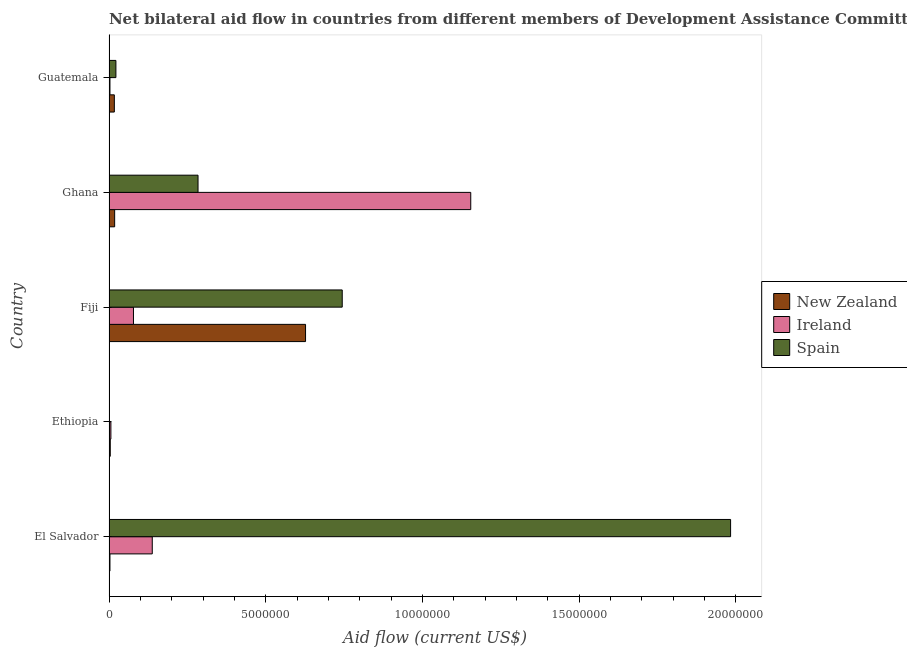Are the number of bars on each tick of the Y-axis equal?
Offer a very short reply. No. How many bars are there on the 3rd tick from the top?
Provide a succinct answer. 3. What is the label of the 5th group of bars from the top?
Keep it short and to the point. El Salvador. In how many cases, is the number of bars for a given country not equal to the number of legend labels?
Ensure brevity in your answer.  1. What is the amount of aid provided by spain in El Salvador?
Make the answer very short. 1.98e+07. Across all countries, what is the maximum amount of aid provided by spain?
Provide a short and direct response. 1.98e+07. Across all countries, what is the minimum amount of aid provided by ireland?
Keep it short and to the point. 3.00e+04. In which country was the amount of aid provided by new zealand maximum?
Offer a very short reply. Fiji. What is the total amount of aid provided by spain in the graph?
Offer a very short reply. 3.03e+07. What is the difference between the amount of aid provided by ireland in Ethiopia and that in Ghana?
Give a very brief answer. -1.15e+07. What is the difference between the amount of aid provided by ireland in Fiji and the amount of aid provided by new zealand in Ethiopia?
Ensure brevity in your answer.  7.40e+05. What is the average amount of aid provided by new zealand per country?
Provide a succinct answer. 1.34e+06. What is the difference between the amount of aid provided by new zealand and amount of aid provided by ireland in Fiji?
Ensure brevity in your answer.  5.49e+06. In how many countries, is the amount of aid provided by ireland greater than 17000000 US$?
Provide a succinct answer. 0. What is the ratio of the amount of aid provided by spain in El Salvador to that in Fiji?
Offer a very short reply. 2.67. Is the amount of aid provided by new zealand in Fiji less than that in Ghana?
Offer a very short reply. No. Is the difference between the amount of aid provided by ireland in Fiji and Ghana greater than the difference between the amount of aid provided by new zealand in Fiji and Ghana?
Ensure brevity in your answer.  No. What is the difference between the highest and the second highest amount of aid provided by ireland?
Offer a very short reply. 1.02e+07. What is the difference between the highest and the lowest amount of aid provided by ireland?
Keep it short and to the point. 1.15e+07. In how many countries, is the amount of aid provided by ireland greater than the average amount of aid provided by ireland taken over all countries?
Your answer should be compact. 1. Is the sum of the amount of aid provided by new zealand in Fiji and Ghana greater than the maximum amount of aid provided by spain across all countries?
Your answer should be compact. No. How many bars are there?
Your response must be concise. 14. Are all the bars in the graph horizontal?
Your answer should be compact. Yes. How many countries are there in the graph?
Provide a succinct answer. 5. Are the values on the major ticks of X-axis written in scientific E-notation?
Provide a succinct answer. No. Does the graph contain any zero values?
Your answer should be very brief. Yes. How are the legend labels stacked?
Your answer should be compact. Vertical. What is the title of the graph?
Your response must be concise. Net bilateral aid flow in countries from different members of Development Assistance Committee. Does "Manufactures" appear as one of the legend labels in the graph?
Ensure brevity in your answer.  No. What is the label or title of the X-axis?
Offer a terse response. Aid flow (current US$). What is the Aid flow (current US$) of New Zealand in El Salvador?
Keep it short and to the point. 3.00e+04. What is the Aid flow (current US$) in Ireland in El Salvador?
Your answer should be compact. 1.38e+06. What is the Aid flow (current US$) in Spain in El Salvador?
Your answer should be compact. 1.98e+07. What is the Aid flow (current US$) of Ireland in Ethiopia?
Your answer should be compact. 6.00e+04. What is the Aid flow (current US$) of New Zealand in Fiji?
Make the answer very short. 6.27e+06. What is the Aid flow (current US$) of Ireland in Fiji?
Give a very brief answer. 7.80e+05. What is the Aid flow (current US$) of Spain in Fiji?
Keep it short and to the point. 7.44e+06. What is the Aid flow (current US$) of Ireland in Ghana?
Provide a short and direct response. 1.15e+07. What is the Aid flow (current US$) in Spain in Ghana?
Ensure brevity in your answer.  2.84e+06. What is the Aid flow (current US$) of Spain in Guatemala?
Offer a terse response. 2.20e+05. Across all countries, what is the maximum Aid flow (current US$) of New Zealand?
Keep it short and to the point. 6.27e+06. Across all countries, what is the maximum Aid flow (current US$) in Ireland?
Provide a short and direct response. 1.15e+07. Across all countries, what is the maximum Aid flow (current US$) in Spain?
Your answer should be compact. 1.98e+07. Across all countries, what is the minimum Aid flow (current US$) in New Zealand?
Your response must be concise. 3.00e+04. Across all countries, what is the minimum Aid flow (current US$) in Spain?
Give a very brief answer. 0. What is the total Aid flow (current US$) in New Zealand in the graph?
Keep it short and to the point. 6.69e+06. What is the total Aid flow (current US$) in Ireland in the graph?
Your answer should be compact. 1.38e+07. What is the total Aid flow (current US$) of Spain in the graph?
Provide a succinct answer. 3.03e+07. What is the difference between the Aid flow (current US$) in Ireland in El Salvador and that in Ethiopia?
Your answer should be compact. 1.32e+06. What is the difference between the Aid flow (current US$) of New Zealand in El Salvador and that in Fiji?
Your answer should be very brief. -6.24e+06. What is the difference between the Aid flow (current US$) of Ireland in El Salvador and that in Fiji?
Give a very brief answer. 6.00e+05. What is the difference between the Aid flow (current US$) in Spain in El Salvador and that in Fiji?
Give a very brief answer. 1.24e+07. What is the difference between the Aid flow (current US$) of New Zealand in El Salvador and that in Ghana?
Make the answer very short. -1.50e+05. What is the difference between the Aid flow (current US$) of Ireland in El Salvador and that in Ghana?
Offer a very short reply. -1.02e+07. What is the difference between the Aid flow (current US$) in Spain in El Salvador and that in Ghana?
Your answer should be very brief. 1.70e+07. What is the difference between the Aid flow (current US$) of Ireland in El Salvador and that in Guatemala?
Provide a succinct answer. 1.35e+06. What is the difference between the Aid flow (current US$) in Spain in El Salvador and that in Guatemala?
Make the answer very short. 1.96e+07. What is the difference between the Aid flow (current US$) in New Zealand in Ethiopia and that in Fiji?
Provide a succinct answer. -6.23e+06. What is the difference between the Aid flow (current US$) in Ireland in Ethiopia and that in Fiji?
Provide a succinct answer. -7.20e+05. What is the difference between the Aid flow (current US$) in New Zealand in Ethiopia and that in Ghana?
Provide a succinct answer. -1.40e+05. What is the difference between the Aid flow (current US$) in Ireland in Ethiopia and that in Ghana?
Provide a succinct answer. -1.15e+07. What is the difference between the Aid flow (current US$) in Ireland in Ethiopia and that in Guatemala?
Offer a terse response. 3.00e+04. What is the difference between the Aid flow (current US$) of New Zealand in Fiji and that in Ghana?
Keep it short and to the point. 6.09e+06. What is the difference between the Aid flow (current US$) in Ireland in Fiji and that in Ghana?
Your answer should be compact. -1.08e+07. What is the difference between the Aid flow (current US$) of Spain in Fiji and that in Ghana?
Give a very brief answer. 4.60e+06. What is the difference between the Aid flow (current US$) in New Zealand in Fiji and that in Guatemala?
Your answer should be very brief. 6.10e+06. What is the difference between the Aid flow (current US$) in Ireland in Fiji and that in Guatemala?
Make the answer very short. 7.50e+05. What is the difference between the Aid flow (current US$) in Spain in Fiji and that in Guatemala?
Provide a short and direct response. 7.22e+06. What is the difference between the Aid flow (current US$) in Ireland in Ghana and that in Guatemala?
Provide a succinct answer. 1.15e+07. What is the difference between the Aid flow (current US$) in Spain in Ghana and that in Guatemala?
Offer a terse response. 2.62e+06. What is the difference between the Aid flow (current US$) of New Zealand in El Salvador and the Aid flow (current US$) of Ireland in Ethiopia?
Your response must be concise. -3.00e+04. What is the difference between the Aid flow (current US$) of New Zealand in El Salvador and the Aid flow (current US$) of Ireland in Fiji?
Your response must be concise. -7.50e+05. What is the difference between the Aid flow (current US$) in New Zealand in El Salvador and the Aid flow (current US$) in Spain in Fiji?
Your response must be concise. -7.41e+06. What is the difference between the Aid flow (current US$) of Ireland in El Salvador and the Aid flow (current US$) of Spain in Fiji?
Give a very brief answer. -6.06e+06. What is the difference between the Aid flow (current US$) of New Zealand in El Salvador and the Aid flow (current US$) of Ireland in Ghana?
Provide a succinct answer. -1.15e+07. What is the difference between the Aid flow (current US$) of New Zealand in El Salvador and the Aid flow (current US$) of Spain in Ghana?
Give a very brief answer. -2.81e+06. What is the difference between the Aid flow (current US$) of Ireland in El Salvador and the Aid flow (current US$) of Spain in Ghana?
Ensure brevity in your answer.  -1.46e+06. What is the difference between the Aid flow (current US$) in Ireland in El Salvador and the Aid flow (current US$) in Spain in Guatemala?
Your answer should be compact. 1.16e+06. What is the difference between the Aid flow (current US$) in New Zealand in Ethiopia and the Aid flow (current US$) in Ireland in Fiji?
Offer a terse response. -7.40e+05. What is the difference between the Aid flow (current US$) of New Zealand in Ethiopia and the Aid flow (current US$) of Spain in Fiji?
Offer a very short reply. -7.40e+06. What is the difference between the Aid flow (current US$) in Ireland in Ethiopia and the Aid flow (current US$) in Spain in Fiji?
Your response must be concise. -7.38e+06. What is the difference between the Aid flow (current US$) in New Zealand in Ethiopia and the Aid flow (current US$) in Ireland in Ghana?
Provide a succinct answer. -1.15e+07. What is the difference between the Aid flow (current US$) in New Zealand in Ethiopia and the Aid flow (current US$) in Spain in Ghana?
Make the answer very short. -2.80e+06. What is the difference between the Aid flow (current US$) in Ireland in Ethiopia and the Aid flow (current US$) in Spain in Ghana?
Keep it short and to the point. -2.78e+06. What is the difference between the Aid flow (current US$) of New Zealand in Ethiopia and the Aid flow (current US$) of Ireland in Guatemala?
Make the answer very short. 10000. What is the difference between the Aid flow (current US$) of New Zealand in Fiji and the Aid flow (current US$) of Ireland in Ghana?
Your answer should be very brief. -5.27e+06. What is the difference between the Aid flow (current US$) of New Zealand in Fiji and the Aid flow (current US$) of Spain in Ghana?
Your response must be concise. 3.43e+06. What is the difference between the Aid flow (current US$) in Ireland in Fiji and the Aid flow (current US$) in Spain in Ghana?
Give a very brief answer. -2.06e+06. What is the difference between the Aid flow (current US$) of New Zealand in Fiji and the Aid flow (current US$) of Ireland in Guatemala?
Offer a very short reply. 6.24e+06. What is the difference between the Aid flow (current US$) in New Zealand in Fiji and the Aid flow (current US$) in Spain in Guatemala?
Keep it short and to the point. 6.05e+06. What is the difference between the Aid flow (current US$) in Ireland in Fiji and the Aid flow (current US$) in Spain in Guatemala?
Make the answer very short. 5.60e+05. What is the difference between the Aid flow (current US$) in Ireland in Ghana and the Aid flow (current US$) in Spain in Guatemala?
Your answer should be compact. 1.13e+07. What is the average Aid flow (current US$) of New Zealand per country?
Offer a very short reply. 1.34e+06. What is the average Aid flow (current US$) in Ireland per country?
Provide a succinct answer. 2.76e+06. What is the average Aid flow (current US$) of Spain per country?
Ensure brevity in your answer.  6.07e+06. What is the difference between the Aid flow (current US$) in New Zealand and Aid flow (current US$) in Ireland in El Salvador?
Ensure brevity in your answer.  -1.35e+06. What is the difference between the Aid flow (current US$) of New Zealand and Aid flow (current US$) of Spain in El Salvador?
Make the answer very short. -1.98e+07. What is the difference between the Aid flow (current US$) of Ireland and Aid flow (current US$) of Spain in El Salvador?
Give a very brief answer. -1.84e+07. What is the difference between the Aid flow (current US$) in New Zealand and Aid flow (current US$) in Ireland in Fiji?
Offer a very short reply. 5.49e+06. What is the difference between the Aid flow (current US$) in New Zealand and Aid flow (current US$) in Spain in Fiji?
Provide a short and direct response. -1.17e+06. What is the difference between the Aid flow (current US$) in Ireland and Aid flow (current US$) in Spain in Fiji?
Your response must be concise. -6.66e+06. What is the difference between the Aid flow (current US$) in New Zealand and Aid flow (current US$) in Ireland in Ghana?
Provide a short and direct response. -1.14e+07. What is the difference between the Aid flow (current US$) in New Zealand and Aid flow (current US$) in Spain in Ghana?
Your answer should be very brief. -2.66e+06. What is the difference between the Aid flow (current US$) in Ireland and Aid flow (current US$) in Spain in Ghana?
Offer a terse response. 8.70e+06. What is the difference between the Aid flow (current US$) of New Zealand and Aid flow (current US$) of Spain in Guatemala?
Give a very brief answer. -5.00e+04. What is the ratio of the Aid flow (current US$) of Ireland in El Salvador to that in Ethiopia?
Provide a short and direct response. 23. What is the ratio of the Aid flow (current US$) of New Zealand in El Salvador to that in Fiji?
Your answer should be very brief. 0. What is the ratio of the Aid flow (current US$) in Ireland in El Salvador to that in Fiji?
Keep it short and to the point. 1.77. What is the ratio of the Aid flow (current US$) in Spain in El Salvador to that in Fiji?
Your answer should be very brief. 2.67. What is the ratio of the Aid flow (current US$) of Ireland in El Salvador to that in Ghana?
Offer a very short reply. 0.12. What is the ratio of the Aid flow (current US$) of Spain in El Salvador to that in Ghana?
Your answer should be compact. 6.98. What is the ratio of the Aid flow (current US$) of New Zealand in El Salvador to that in Guatemala?
Give a very brief answer. 0.18. What is the ratio of the Aid flow (current US$) in Spain in El Salvador to that in Guatemala?
Offer a terse response. 90.14. What is the ratio of the Aid flow (current US$) of New Zealand in Ethiopia to that in Fiji?
Give a very brief answer. 0.01. What is the ratio of the Aid flow (current US$) in Ireland in Ethiopia to that in Fiji?
Your answer should be compact. 0.08. What is the ratio of the Aid flow (current US$) in New Zealand in Ethiopia to that in Ghana?
Your answer should be very brief. 0.22. What is the ratio of the Aid flow (current US$) of Ireland in Ethiopia to that in Ghana?
Provide a succinct answer. 0.01. What is the ratio of the Aid flow (current US$) in New Zealand in Ethiopia to that in Guatemala?
Ensure brevity in your answer.  0.24. What is the ratio of the Aid flow (current US$) in New Zealand in Fiji to that in Ghana?
Keep it short and to the point. 34.83. What is the ratio of the Aid flow (current US$) in Ireland in Fiji to that in Ghana?
Ensure brevity in your answer.  0.07. What is the ratio of the Aid flow (current US$) of Spain in Fiji to that in Ghana?
Give a very brief answer. 2.62. What is the ratio of the Aid flow (current US$) in New Zealand in Fiji to that in Guatemala?
Your answer should be compact. 36.88. What is the ratio of the Aid flow (current US$) in Spain in Fiji to that in Guatemala?
Ensure brevity in your answer.  33.82. What is the ratio of the Aid flow (current US$) of New Zealand in Ghana to that in Guatemala?
Provide a short and direct response. 1.06. What is the ratio of the Aid flow (current US$) of Ireland in Ghana to that in Guatemala?
Give a very brief answer. 384.67. What is the ratio of the Aid flow (current US$) of Spain in Ghana to that in Guatemala?
Offer a terse response. 12.91. What is the difference between the highest and the second highest Aid flow (current US$) of New Zealand?
Keep it short and to the point. 6.09e+06. What is the difference between the highest and the second highest Aid flow (current US$) in Ireland?
Give a very brief answer. 1.02e+07. What is the difference between the highest and the second highest Aid flow (current US$) of Spain?
Your answer should be very brief. 1.24e+07. What is the difference between the highest and the lowest Aid flow (current US$) of New Zealand?
Your response must be concise. 6.24e+06. What is the difference between the highest and the lowest Aid flow (current US$) in Ireland?
Keep it short and to the point. 1.15e+07. What is the difference between the highest and the lowest Aid flow (current US$) in Spain?
Your answer should be very brief. 1.98e+07. 